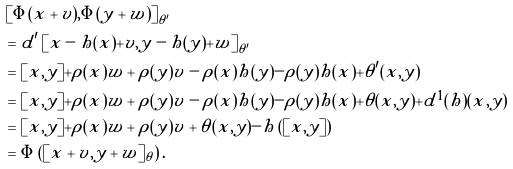<formula> <loc_0><loc_0><loc_500><loc_500>& \left [ \Phi ( x + v ) , \Phi ( y + w ) \right ] _ { \theta ^ { \prime } } \\ & = d ^ { \prime } \left [ x - h ( x ) + v , y - h ( y ) + w \right ] _ { \theta ^ { \prime } } \\ & = [ x , y ] + \rho ( x ) w + \rho ( y ) v - \rho ( x ) h ( y ) - \rho ( y ) h ( x ) + \theta ^ { \prime } ( x , y ) \\ & = [ x , y ] + \rho ( x ) w + \rho ( y ) v - \rho ( x ) h ( y ) - \rho ( y ) h ( x ) + \theta ( x , y ) + d ^ { 1 } ( h ) ( x , y ) \\ & = [ x , y ] + \rho ( x ) w + \rho ( y ) v + \theta ( x , y ) - h \left ( [ x , y ] \right ) \\ & = \Phi \left ( [ x + v , y + w ] _ { \theta } \right ) .</formula> 